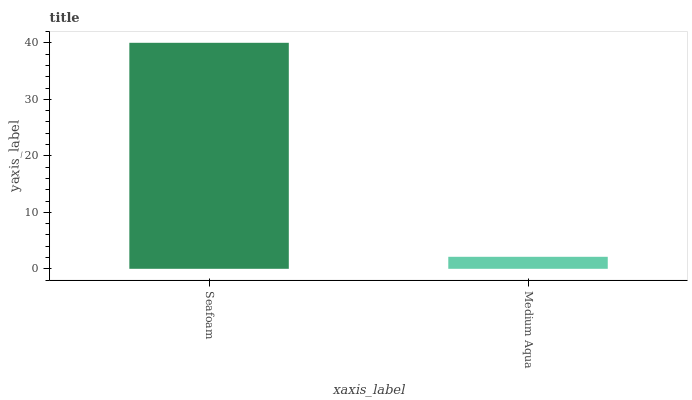Is Medium Aqua the minimum?
Answer yes or no. Yes. Is Seafoam the maximum?
Answer yes or no. Yes. Is Medium Aqua the maximum?
Answer yes or no. No. Is Seafoam greater than Medium Aqua?
Answer yes or no. Yes. Is Medium Aqua less than Seafoam?
Answer yes or no. Yes. Is Medium Aqua greater than Seafoam?
Answer yes or no. No. Is Seafoam less than Medium Aqua?
Answer yes or no. No. Is Seafoam the high median?
Answer yes or no. Yes. Is Medium Aqua the low median?
Answer yes or no. Yes. Is Medium Aqua the high median?
Answer yes or no. No. Is Seafoam the low median?
Answer yes or no. No. 